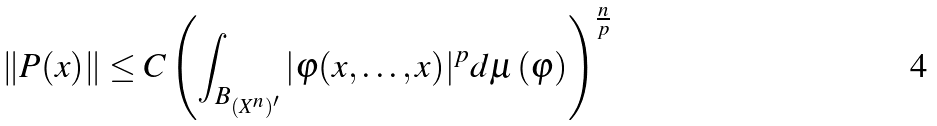<formula> <loc_0><loc_0><loc_500><loc_500>\| P ( x ) \| \leq C \left ( \int _ { B _ { ( X ^ { n } ) ^ { \prime } } } | \varphi ( x , \dots , x ) | ^ { p } d \mu \left ( \varphi \right ) \right ) ^ { \frac { n } { p } }</formula> 